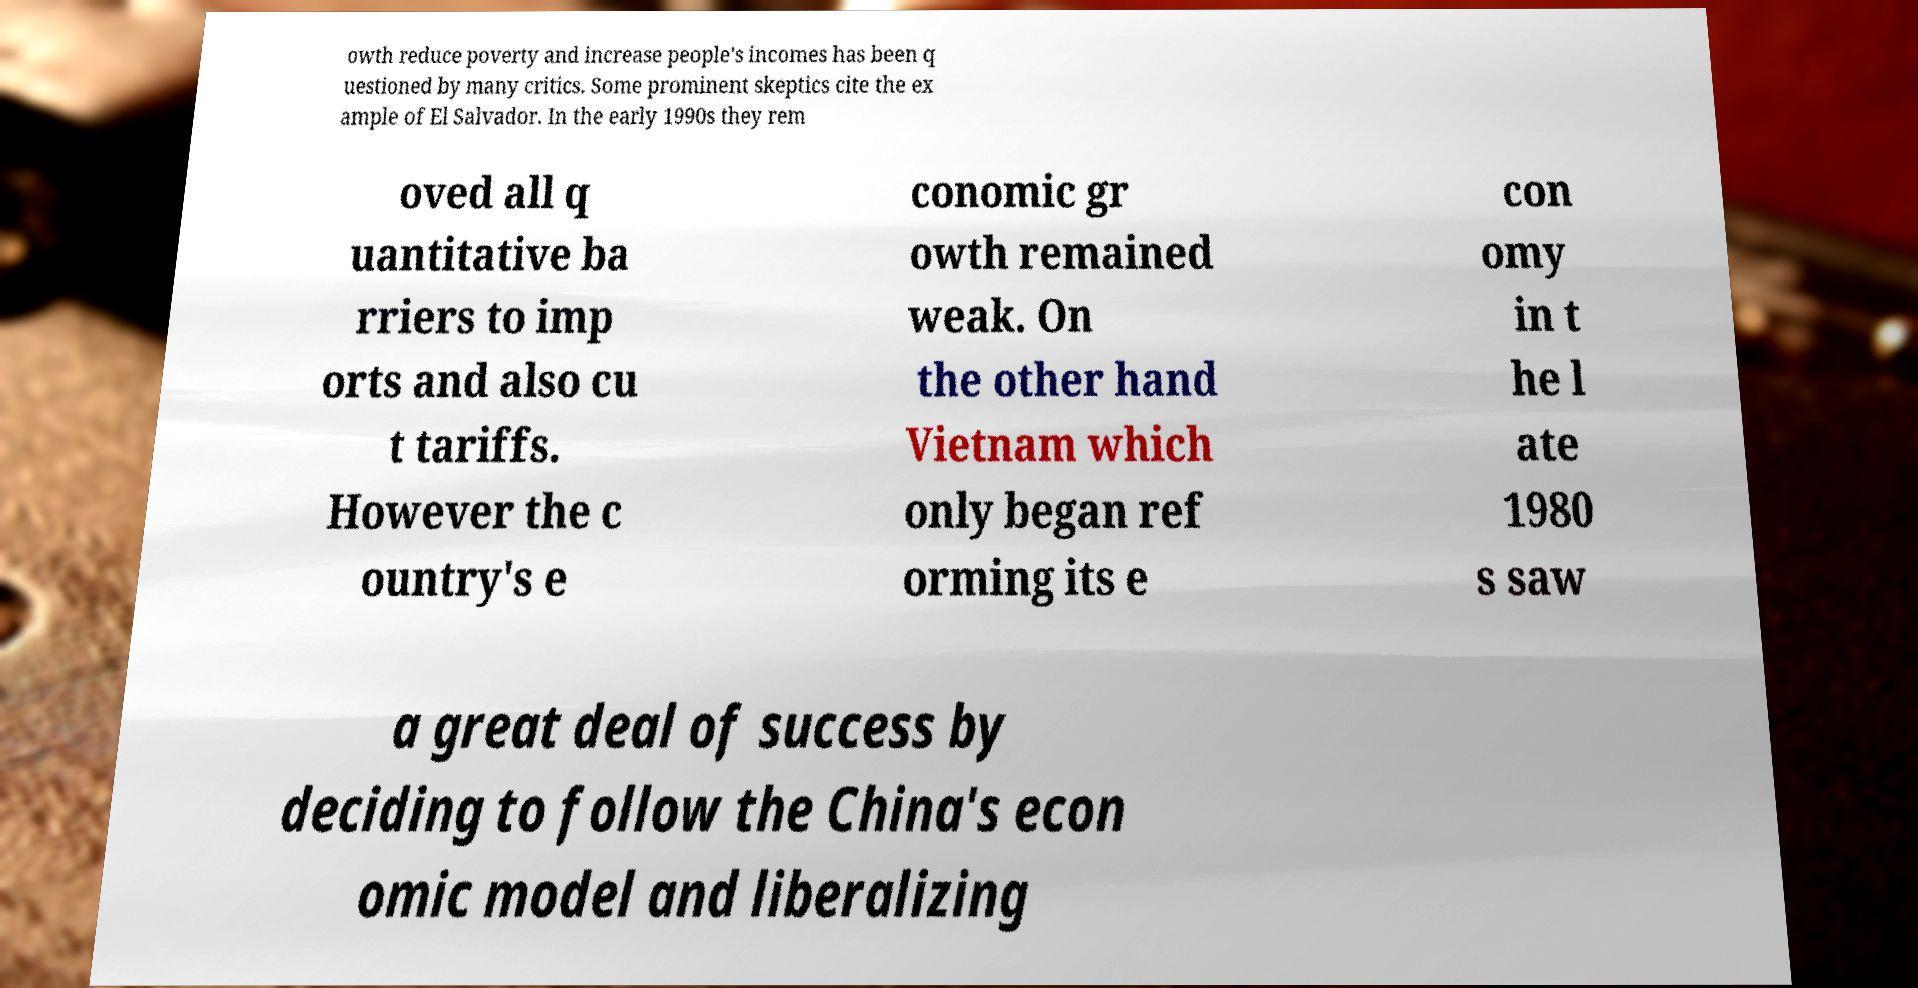Please identify and transcribe the text found in this image. owth reduce poverty and increase people's incomes has been q uestioned by many critics. Some prominent skeptics cite the ex ample of El Salvador. In the early 1990s they rem oved all q uantitative ba rriers to imp orts and also cu t tariffs. However the c ountry's e conomic gr owth remained weak. On the other hand Vietnam which only began ref orming its e con omy in t he l ate 1980 s saw a great deal of success by deciding to follow the China's econ omic model and liberalizing 